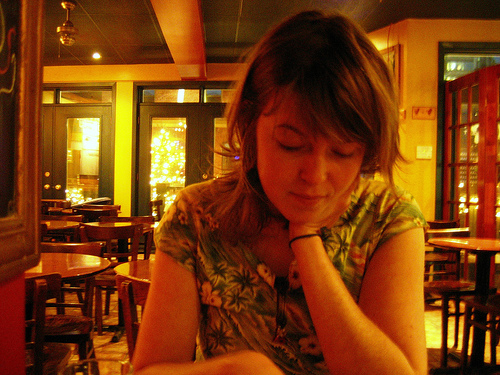<image>
Is the girl behind the light switch? No. The girl is not behind the light switch. From this viewpoint, the girl appears to be positioned elsewhere in the scene. 